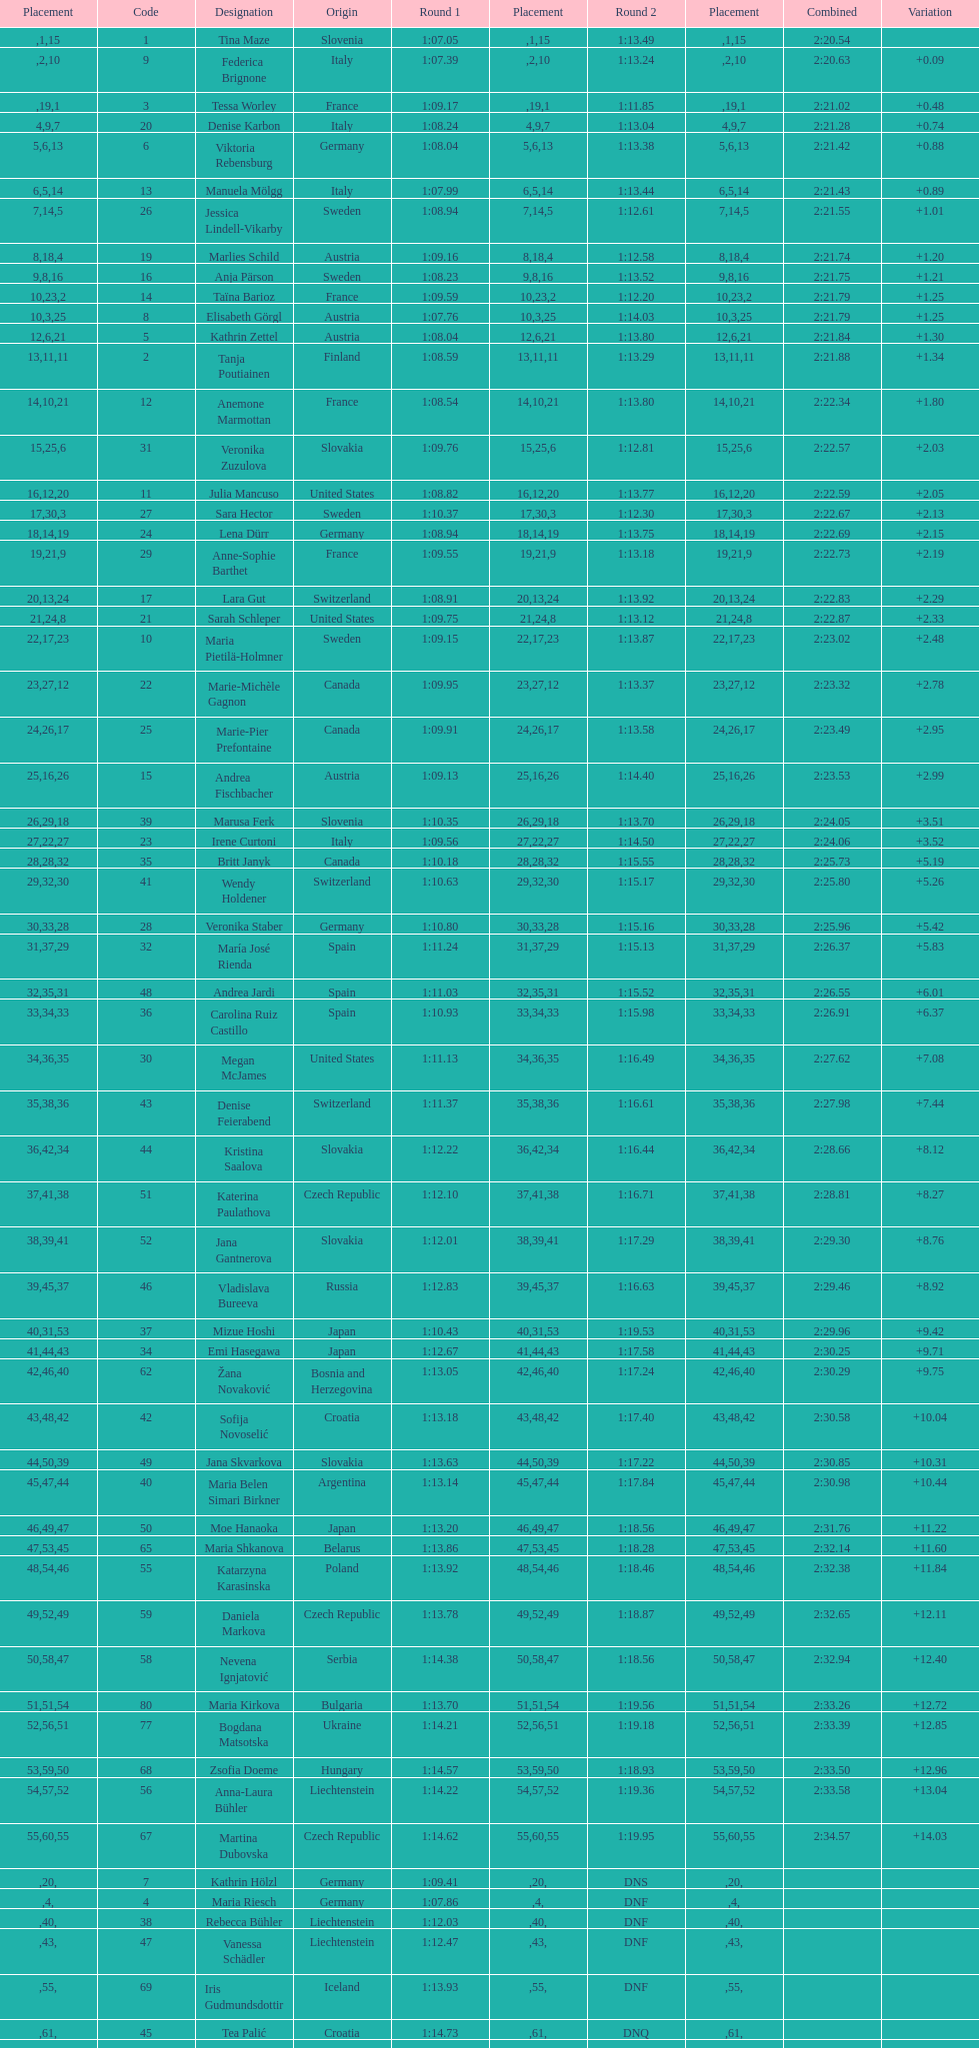How many total names are there? 116. 